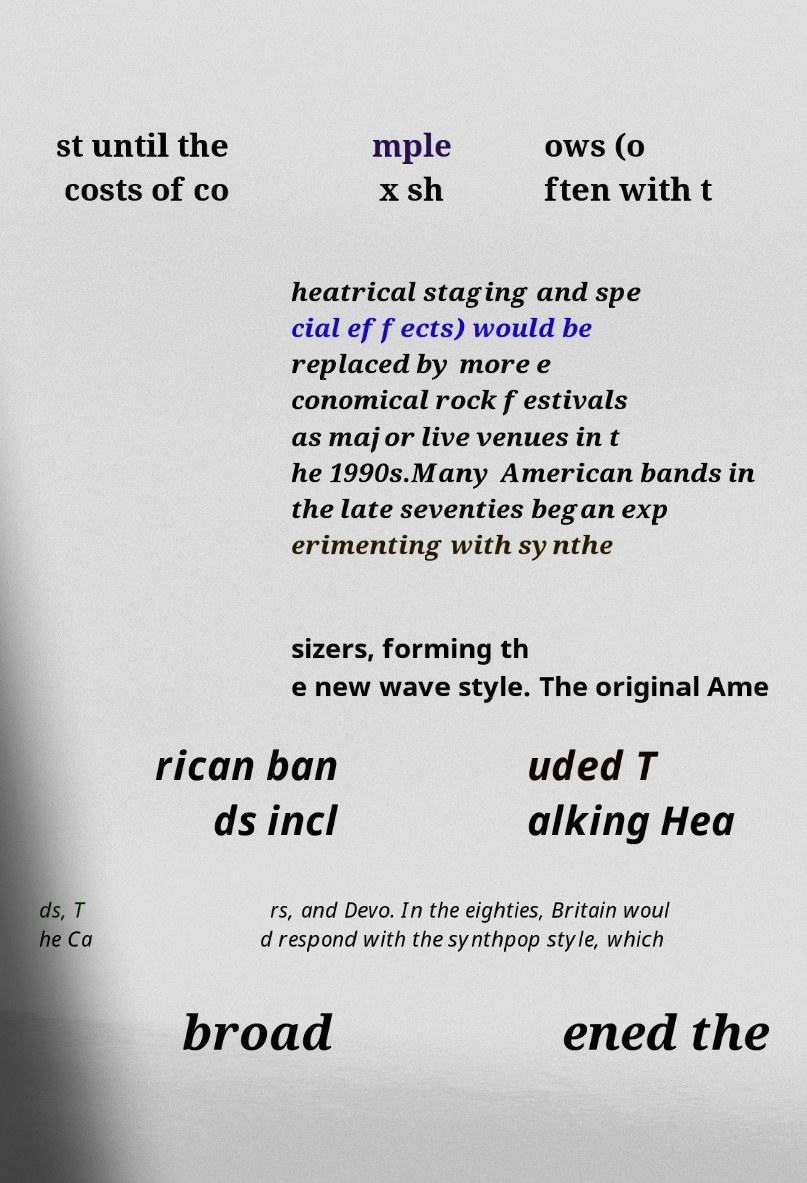Could you assist in decoding the text presented in this image and type it out clearly? st until the costs of co mple x sh ows (o ften with t heatrical staging and spe cial effects) would be replaced by more e conomical rock festivals as major live venues in t he 1990s.Many American bands in the late seventies began exp erimenting with synthe sizers, forming th e new wave style. The original Ame rican ban ds incl uded T alking Hea ds, T he Ca rs, and Devo. In the eighties, Britain woul d respond with the synthpop style, which broad ened the 